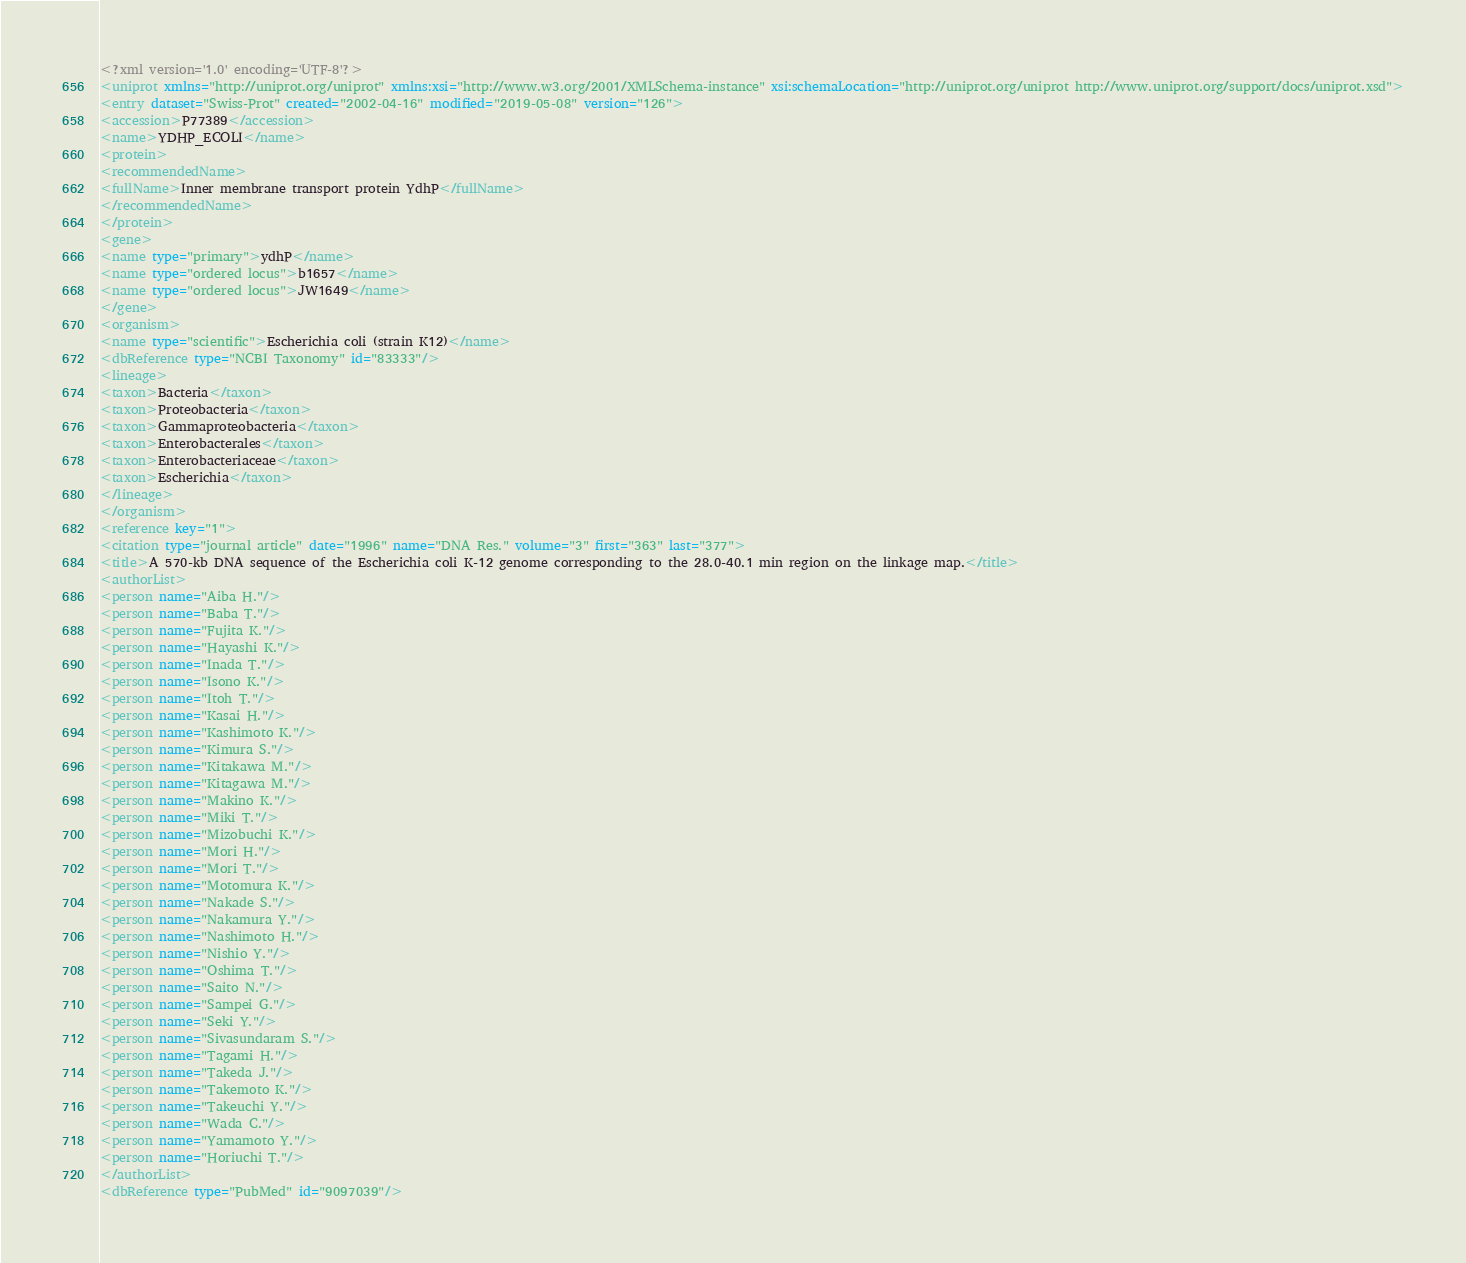<code> <loc_0><loc_0><loc_500><loc_500><_XML_><?xml version='1.0' encoding='UTF-8'?>
<uniprot xmlns="http://uniprot.org/uniprot" xmlns:xsi="http://www.w3.org/2001/XMLSchema-instance" xsi:schemaLocation="http://uniprot.org/uniprot http://www.uniprot.org/support/docs/uniprot.xsd">
<entry dataset="Swiss-Prot" created="2002-04-16" modified="2019-05-08" version="126">
<accession>P77389</accession>
<name>YDHP_ECOLI</name>
<protein>
<recommendedName>
<fullName>Inner membrane transport protein YdhP</fullName>
</recommendedName>
</protein>
<gene>
<name type="primary">ydhP</name>
<name type="ordered locus">b1657</name>
<name type="ordered locus">JW1649</name>
</gene>
<organism>
<name type="scientific">Escherichia coli (strain K12)</name>
<dbReference type="NCBI Taxonomy" id="83333"/>
<lineage>
<taxon>Bacteria</taxon>
<taxon>Proteobacteria</taxon>
<taxon>Gammaproteobacteria</taxon>
<taxon>Enterobacterales</taxon>
<taxon>Enterobacteriaceae</taxon>
<taxon>Escherichia</taxon>
</lineage>
</organism>
<reference key="1">
<citation type="journal article" date="1996" name="DNA Res." volume="3" first="363" last="377">
<title>A 570-kb DNA sequence of the Escherichia coli K-12 genome corresponding to the 28.0-40.1 min region on the linkage map.</title>
<authorList>
<person name="Aiba H."/>
<person name="Baba T."/>
<person name="Fujita K."/>
<person name="Hayashi K."/>
<person name="Inada T."/>
<person name="Isono K."/>
<person name="Itoh T."/>
<person name="Kasai H."/>
<person name="Kashimoto K."/>
<person name="Kimura S."/>
<person name="Kitakawa M."/>
<person name="Kitagawa M."/>
<person name="Makino K."/>
<person name="Miki T."/>
<person name="Mizobuchi K."/>
<person name="Mori H."/>
<person name="Mori T."/>
<person name="Motomura K."/>
<person name="Nakade S."/>
<person name="Nakamura Y."/>
<person name="Nashimoto H."/>
<person name="Nishio Y."/>
<person name="Oshima T."/>
<person name="Saito N."/>
<person name="Sampei G."/>
<person name="Seki Y."/>
<person name="Sivasundaram S."/>
<person name="Tagami H."/>
<person name="Takeda J."/>
<person name="Takemoto K."/>
<person name="Takeuchi Y."/>
<person name="Wada C."/>
<person name="Yamamoto Y."/>
<person name="Horiuchi T."/>
</authorList>
<dbReference type="PubMed" id="9097039"/></code> 